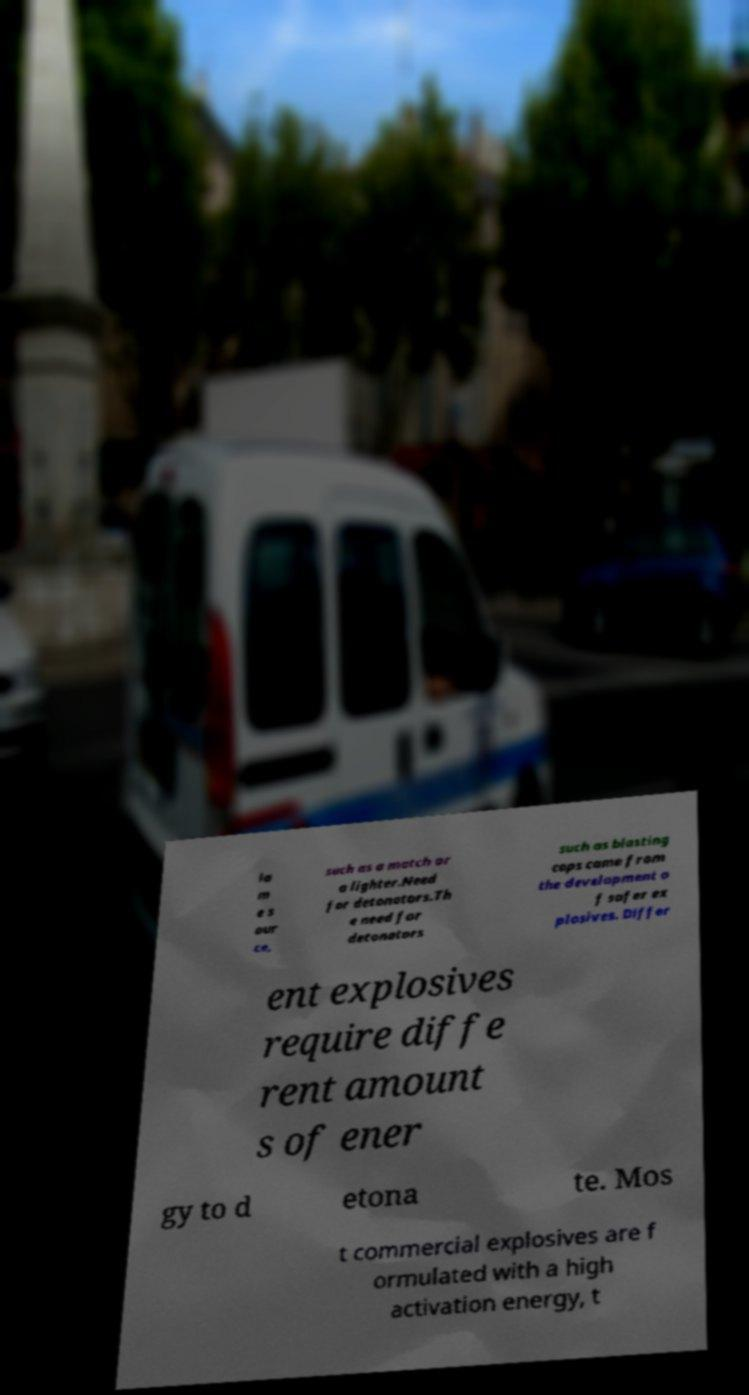Please read and relay the text visible in this image. What does it say? la m e s our ce, such as a match or a lighter.Need for detonators.Th e need for detonators such as blasting caps came from the development o f safer ex plosives. Differ ent explosives require diffe rent amount s of ener gy to d etona te. Mos t commercial explosives are f ormulated with a high activation energy, t 